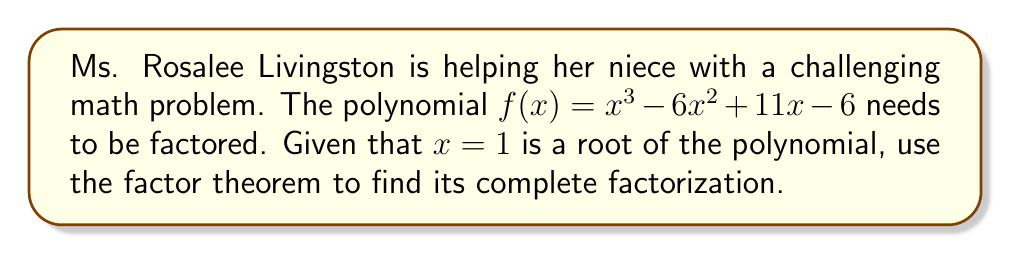Show me your answer to this math problem. Let's approach this step-by-step:

1) We're given that $x = 1$ is a root of the polynomial. This means that $(x - 1)$ is a factor of $f(x)$.

2) Using the factor theorem, we can divide $f(x)$ by $(x - 1)$ to find the other factor, which will be a quadratic polynomial.

3) Let's perform polynomial long division:

   $$\begin{array}{r}
   x^2 - 5x + 6 \\
   x - 1 \enclose{longdiv}{x^3 - 6x^2 + 11x - 6} \\
   \underline{x^3 - x^2} \\
   -5x^2 + 11x \\
   \underline{-5x^2 + 5x} \\
   6x - 6 \\
   \underline{6x - 6} \\
   0
   \end{array}$$

4) The result of the division is $x^2 - 5x + 6$, with no remainder. This confirms that $(x - 1)$ is indeed a factor.

5) Now we need to factor the quadratic term $x^2 - 5x + 6$:
   
   Finding two numbers that multiply to give 6 and add to give -5, we get -2 and -3.

6) So, $x^2 - 5x + 6 = (x - 2)(x - 3)$

7) Therefore, the complete factorization is:

   $f(x) = (x - 1)(x - 2)(x - 3)$
Answer: $f(x) = (x - 1)(x - 2)(x - 3)$ 